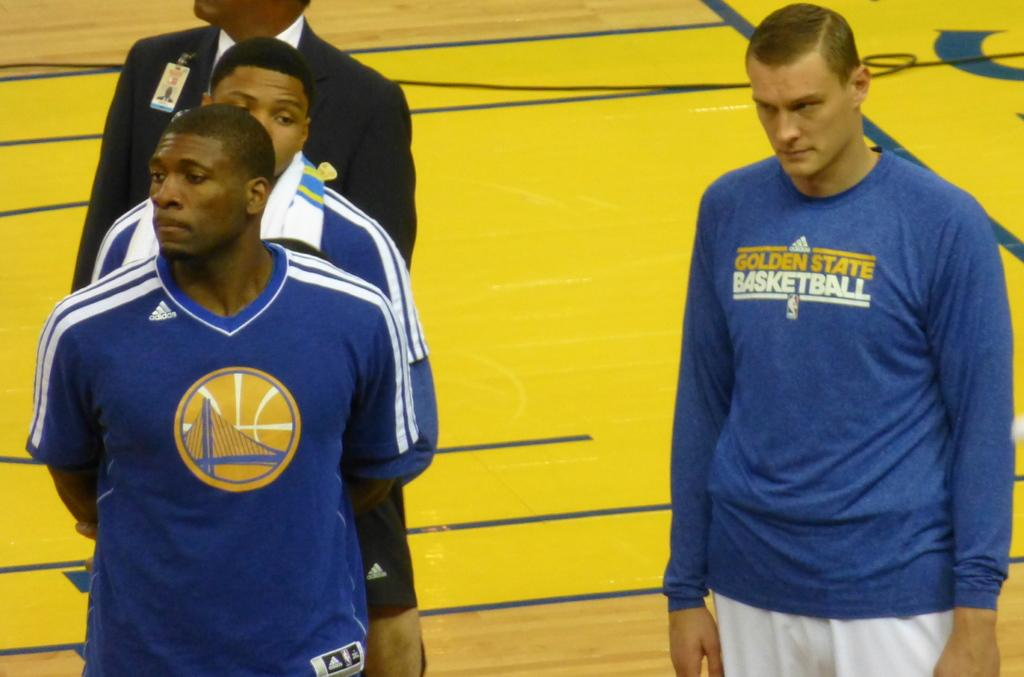<image>
Render a clear and concise summary of the photo. Men standing on a court with Golden State Basketball shirts and logos. 